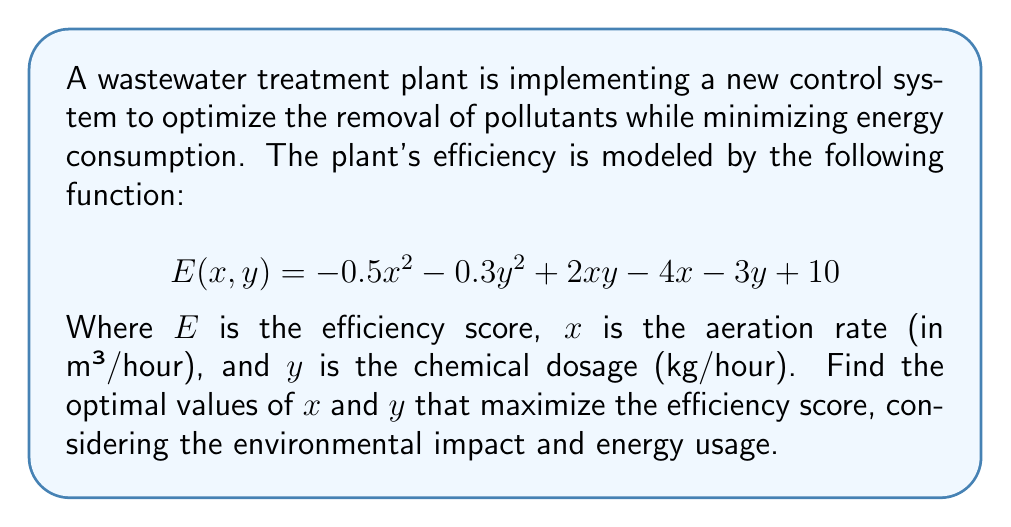Can you answer this question? To find the optimal values of $x$ and $y$ that maximize the efficiency score, we need to find the critical points of the function $E(x, y)$ by taking partial derivatives with respect to $x$ and $y$ and setting them equal to zero.

1. Find partial derivatives:
   $$\frac{\partial E}{\partial x} = -x + 2y - 4$$
   $$\frac{\partial E}{\partial y} = -0.6y + 2x - 3$$

2. Set partial derivatives to zero and solve the system of equations:
   $$-x + 2y - 4 = 0 \quad (1)$$
   $$-0.6y + 2x - 3 = 0 \quad (2)$$

3. Multiply equation (2) by 5 to eliminate fractions:
   $$-x + 2y - 4 = 0 \quad (1)$$
   $$-3y + 10x - 15 = 0 \quad (3)$$

4. Solve the system of equations:
   Multiply equation (1) by 10 and equation (3) by 2:
   $$-10x + 20y - 40 = 0 \quad (4)$$
   $$-6y + 20x - 30 = 0 \quad (5)$$

   Subtract equation (5) from equation (4):
   $$-30x + 26y - 10 = 0 \quad (6)$$

   Solve for y in terms of x using equation (6):
   $$y = \frac{30x + 10}{26} \quad (7)$$

   Substitute (7) into equation (1):
   $$-x + 2(\frac{30x + 10}{26}) - 4 = 0$$
   $$-x + \frac{60x + 20}{26} - 4 = 0$$
   $$-26x + 60x + 20 - 104 = 0$$
   $$34x = 84$$
   $$x = \frac{84}{34} = \frac{42}{17}$$

   Substitute this value of x back into equation (7) to find y:
   $$y = \frac{30(\frac{42}{17}) + 10}{26} = \frac{1260 + 170}{442} = \frac{1430}{442} = \frac{715}{221}$$

5. Verify that this critical point is a maximum by checking the second partial derivatives:
   $$\frac{\partial^2 E}{\partial x^2} = -1$$
   $$\frac{\partial^2 E}{\partial y^2} = -0.6$$
   $$\frac{\partial^2 E}{\partial x \partial y} = \frac{\partial^2 E}{\partial y \partial x} = 2$$

   The Hessian matrix is:
   $$H = \begin{bmatrix} -1 & 2 \\ 2 & -0.6 \end{bmatrix}$$

   The determinant of H is: $(-1)(-0.6) - (2)(2) = 0.6 - 4 = -3.4 < 0$
   
   Since the determinant is negative and $\frac{\partial^2 E}{\partial x^2} < 0$, this critical point is a maximum.

Therefore, the optimal values that maximize the efficiency score are $x = \frac{42}{17}$ and $y = \frac{715}{221}$.
Answer: The optimal values are:
Aeration rate: $x = \frac{42}{17} \approx 2.47$ m³/hour
Chemical dosage: $y = \frac{715}{221} \approx 3.24$ kg/hour 